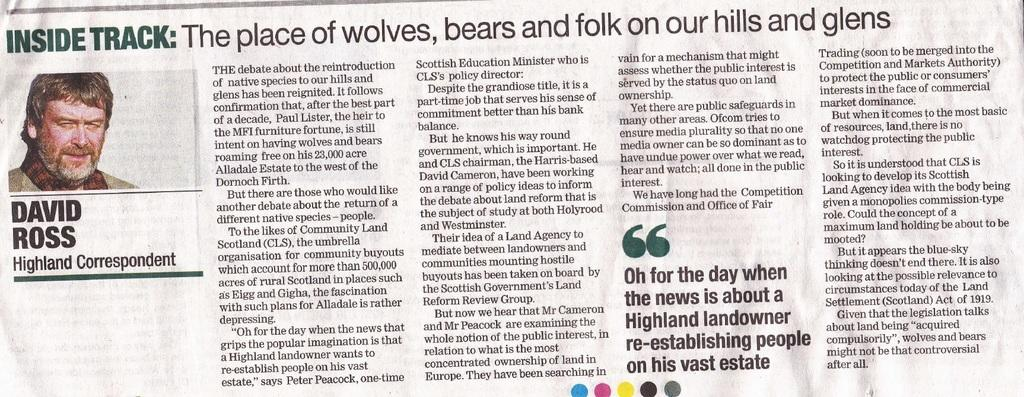What type of print media is visible in the image? There is a part of a newspaper in the image. What can be seen on the newspaper? There is a person's image on the newspaper. How many dolls are present in the image? There are no dolls present in the image. What type of wound is visible on the person's image in the newspaper? There is no wound visible on the person's image in the newspaper, as the image only shows a person's face or upper body. 